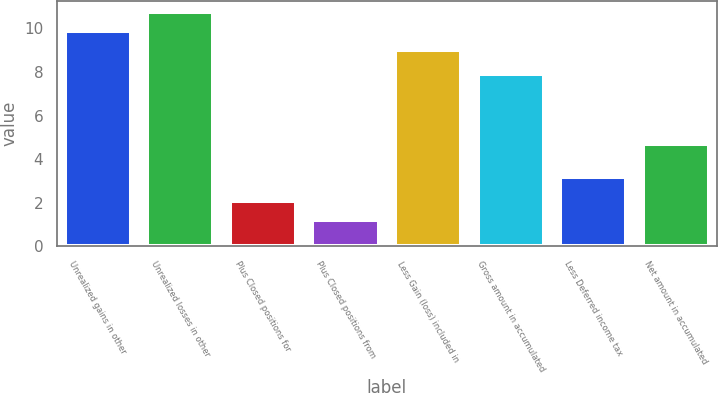Convert chart to OTSL. <chart><loc_0><loc_0><loc_500><loc_500><bar_chart><fcel>Unrealized gains in other<fcel>Unrealized losses in other<fcel>Plus Closed positions for<fcel>Plus Closed positions from<fcel>Less Gain (loss) included in<fcel>Gross amount in accumulated<fcel>Less Deferred income tax<fcel>Net amount in accumulated<nl><fcel>9.87<fcel>10.74<fcel>2.07<fcel>1.2<fcel>9<fcel>7.9<fcel>3.2<fcel>4.7<nl></chart> 